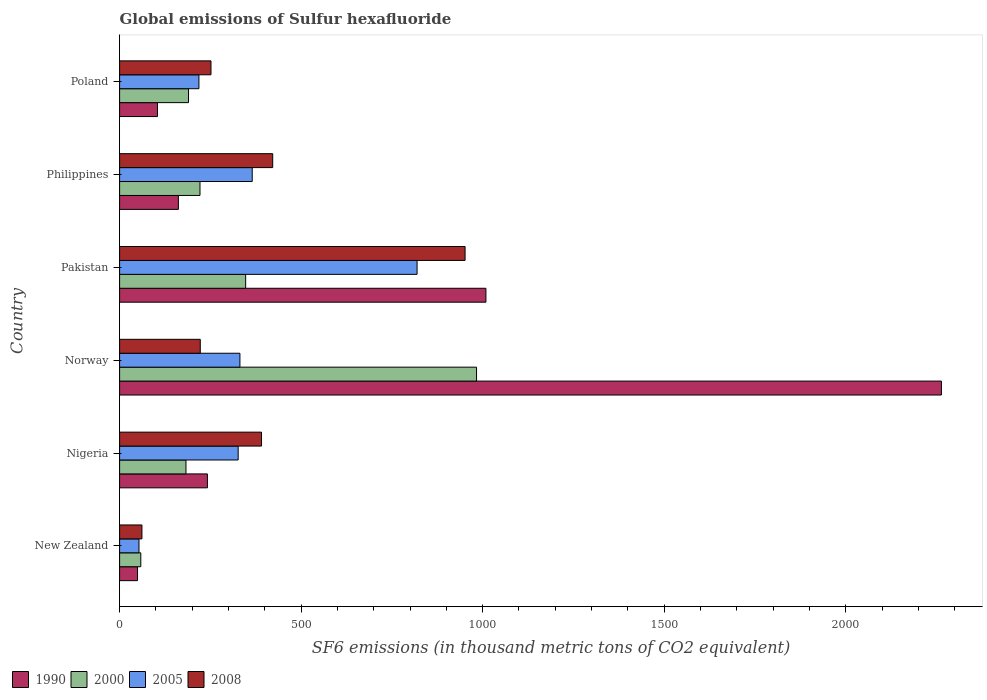Are the number of bars on each tick of the Y-axis equal?
Give a very brief answer. Yes. How many bars are there on the 6th tick from the bottom?
Your answer should be very brief. 4. What is the label of the 6th group of bars from the top?
Ensure brevity in your answer.  New Zealand. In how many cases, is the number of bars for a given country not equal to the number of legend labels?
Keep it short and to the point. 0. What is the global emissions of Sulfur hexafluoride in 1990 in Norway?
Make the answer very short. 2263.6. Across all countries, what is the maximum global emissions of Sulfur hexafluoride in 2000?
Offer a terse response. 983.2. Across all countries, what is the minimum global emissions of Sulfur hexafluoride in 2008?
Offer a very short reply. 61.5. In which country was the global emissions of Sulfur hexafluoride in 2008 minimum?
Keep it short and to the point. New Zealand. What is the total global emissions of Sulfur hexafluoride in 2000 in the graph?
Give a very brief answer. 1982.8. What is the difference between the global emissions of Sulfur hexafluoride in 1990 in New Zealand and that in Nigeria?
Your response must be concise. -192.5. What is the difference between the global emissions of Sulfur hexafluoride in 2000 in Nigeria and the global emissions of Sulfur hexafluoride in 2005 in Norway?
Keep it short and to the point. -148.6. What is the average global emissions of Sulfur hexafluoride in 2005 per country?
Make the answer very short. 352.43. What is the difference between the global emissions of Sulfur hexafluoride in 2005 and global emissions of Sulfur hexafluoride in 2008 in Nigeria?
Give a very brief answer. -64.3. What is the ratio of the global emissions of Sulfur hexafluoride in 2008 in Pakistan to that in Philippines?
Provide a short and direct response. 2.26. Is the global emissions of Sulfur hexafluoride in 1990 in Nigeria less than that in Philippines?
Your response must be concise. No. Is the difference between the global emissions of Sulfur hexafluoride in 2005 in Pakistan and Poland greater than the difference between the global emissions of Sulfur hexafluoride in 2008 in Pakistan and Poland?
Your answer should be very brief. No. What is the difference between the highest and the second highest global emissions of Sulfur hexafluoride in 2008?
Offer a very short reply. 529.9. What is the difference between the highest and the lowest global emissions of Sulfur hexafluoride in 1990?
Give a very brief answer. 2214.2. In how many countries, is the global emissions of Sulfur hexafluoride in 2000 greater than the average global emissions of Sulfur hexafluoride in 2000 taken over all countries?
Your response must be concise. 2. Is the sum of the global emissions of Sulfur hexafluoride in 1990 in Nigeria and Pakistan greater than the maximum global emissions of Sulfur hexafluoride in 2005 across all countries?
Provide a succinct answer. Yes. Is it the case that in every country, the sum of the global emissions of Sulfur hexafluoride in 2005 and global emissions of Sulfur hexafluoride in 2008 is greater than the sum of global emissions of Sulfur hexafluoride in 2000 and global emissions of Sulfur hexafluoride in 1990?
Make the answer very short. No. What does the 4th bar from the top in Pakistan represents?
Your answer should be compact. 1990. Are all the bars in the graph horizontal?
Your answer should be very brief. Yes. Are the values on the major ticks of X-axis written in scientific E-notation?
Make the answer very short. No. Does the graph contain grids?
Your response must be concise. No. Where does the legend appear in the graph?
Provide a short and direct response. Bottom left. How are the legend labels stacked?
Make the answer very short. Horizontal. What is the title of the graph?
Give a very brief answer. Global emissions of Sulfur hexafluoride. What is the label or title of the X-axis?
Your answer should be very brief. SF6 emissions (in thousand metric tons of CO2 equivalent). What is the SF6 emissions (in thousand metric tons of CO2 equivalent) of 1990 in New Zealand?
Your response must be concise. 49.4. What is the SF6 emissions (in thousand metric tons of CO2 equivalent) in 2000 in New Zealand?
Offer a terse response. 58.4. What is the SF6 emissions (in thousand metric tons of CO2 equivalent) in 2005 in New Zealand?
Offer a terse response. 53.4. What is the SF6 emissions (in thousand metric tons of CO2 equivalent) of 2008 in New Zealand?
Provide a succinct answer. 61.5. What is the SF6 emissions (in thousand metric tons of CO2 equivalent) in 1990 in Nigeria?
Give a very brief answer. 241.9. What is the SF6 emissions (in thousand metric tons of CO2 equivalent) in 2000 in Nigeria?
Offer a terse response. 182.8. What is the SF6 emissions (in thousand metric tons of CO2 equivalent) of 2005 in Nigeria?
Your response must be concise. 326.6. What is the SF6 emissions (in thousand metric tons of CO2 equivalent) of 2008 in Nigeria?
Your response must be concise. 390.9. What is the SF6 emissions (in thousand metric tons of CO2 equivalent) in 1990 in Norway?
Give a very brief answer. 2263.6. What is the SF6 emissions (in thousand metric tons of CO2 equivalent) in 2000 in Norway?
Offer a terse response. 983.2. What is the SF6 emissions (in thousand metric tons of CO2 equivalent) in 2005 in Norway?
Your answer should be compact. 331.4. What is the SF6 emissions (in thousand metric tons of CO2 equivalent) of 2008 in Norway?
Offer a very short reply. 222.2. What is the SF6 emissions (in thousand metric tons of CO2 equivalent) in 1990 in Pakistan?
Your answer should be compact. 1009. What is the SF6 emissions (in thousand metric tons of CO2 equivalent) of 2000 in Pakistan?
Make the answer very short. 347.2. What is the SF6 emissions (in thousand metric tons of CO2 equivalent) of 2005 in Pakistan?
Offer a very short reply. 819.4. What is the SF6 emissions (in thousand metric tons of CO2 equivalent) of 2008 in Pakistan?
Keep it short and to the point. 951.6. What is the SF6 emissions (in thousand metric tons of CO2 equivalent) of 1990 in Philippines?
Make the answer very short. 161.9. What is the SF6 emissions (in thousand metric tons of CO2 equivalent) in 2000 in Philippines?
Provide a short and direct response. 221.4. What is the SF6 emissions (in thousand metric tons of CO2 equivalent) in 2005 in Philippines?
Ensure brevity in your answer.  365.3. What is the SF6 emissions (in thousand metric tons of CO2 equivalent) of 2008 in Philippines?
Offer a terse response. 421.7. What is the SF6 emissions (in thousand metric tons of CO2 equivalent) in 1990 in Poland?
Your response must be concise. 104.3. What is the SF6 emissions (in thousand metric tons of CO2 equivalent) of 2000 in Poland?
Ensure brevity in your answer.  189.8. What is the SF6 emissions (in thousand metric tons of CO2 equivalent) in 2005 in Poland?
Your answer should be very brief. 218.5. What is the SF6 emissions (in thousand metric tons of CO2 equivalent) in 2008 in Poland?
Your response must be concise. 251.7. Across all countries, what is the maximum SF6 emissions (in thousand metric tons of CO2 equivalent) of 1990?
Provide a short and direct response. 2263.6. Across all countries, what is the maximum SF6 emissions (in thousand metric tons of CO2 equivalent) in 2000?
Your answer should be very brief. 983.2. Across all countries, what is the maximum SF6 emissions (in thousand metric tons of CO2 equivalent) in 2005?
Offer a terse response. 819.4. Across all countries, what is the maximum SF6 emissions (in thousand metric tons of CO2 equivalent) of 2008?
Give a very brief answer. 951.6. Across all countries, what is the minimum SF6 emissions (in thousand metric tons of CO2 equivalent) in 1990?
Your response must be concise. 49.4. Across all countries, what is the minimum SF6 emissions (in thousand metric tons of CO2 equivalent) of 2000?
Keep it short and to the point. 58.4. Across all countries, what is the minimum SF6 emissions (in thousand metric tons of CO2 equivalent) of 2005?
Make the answer very short. 53.4. Across all countries, what is the minimum SF6 emissions (in thousand metric tons of CO2 equivalent) in 2008?
Your answer should be very brief. 61.5. What is the total SF6 emissions (in thousand metric tons of CO2 equivalent) in 1990 in the graph?
Your response must be concise. 3830.1. What is the total SF6 emissions (in thousand metric tons of CO2 equivalent) in 2000 in the graph?
Your answer should be compact. 1982.8. What is the total SF6 emissions (in thousand metric tons of CO2 equivalent) of 2005 in the graph?
Your answer should be compact. 2114.6. What is the total SF6 emissions (in thousand metric tons of CO2 equivalent) of 2008 in the graph?
Offer a very short reply. 2299.6. What is the difference between the SF6 emissions (in thousand metric tons of CO2 equivalent) of 1990 in New Zealand and that in Nigeria?
Your answer should be very brief. -192.5. What is the difference between the SF6 emissions (in thousand metric tons of CO2 equivalent) of 2000 in New Zealand and that in Nigeria?
Your answer should be very brief. -124.4. What is the difference between the SF6 emissions (in thousand metric tons of CO2 equivalent) in 2005 in New Zealand and that in Nigeria?
Your answer should be compact. -273.2. What is the difference between the SF6 emissions (in thousand metric tons of CO2 equivalent) in 2008 in New Zealand and that in Nigeria?
Your answer should be very brief. -329.4. What is the difference between the SF6 emissions (in thousand metric tons of CO2 equivalent) of 1990 in New Zealand and that in Norway?
Offer a very short reply. -2214.2. What is the difference between the SF6 emissions (in thousand metric tons of CO2 equivalent) of 2000 in New Zealand and that in Norway?
Your answer should be compact. -924.8. What is the difference between the SF6 emissions (in thousand metric tons of CO2 equivalent) of 2005 in New Zealand and that in Norway?
Your response must be concise. -278. What is the difference between the SF6 emissions (in thousand metric tons of CO2 equivalent) of 2008 in New Zealand and that in Norway?
Your answer should be very brief. -160.7. What is the difference between the SF6 emissions (in thousand metric tons of CO2 equivalent) of 1990 in New Zealand and that in Pakistan?
Offer a terse response. -959.6. What is the difference between the SF6 emissions (in thousand metric tons of CO2 equivalent) in 2000 in New Zealand and that in Pakistan?
Provide a succinct answer. -288.8. What is the difference between the SF6 emissions (in thousand metric tons of CO2 equivalent) in 2005 in New Zealand and that in Pakistan?
Provide a succinct answer. -766. What is the difference between the SF6 emissions (in thousand metric tons of CO2 equivalent) in 2008 in New Zealand and that in Pakistan?
Offer a terse response. -890.1. What is the difference between the SF6 emissions (in thousand metric tons of CO2 equivalent) of 1990 in New Zealand and that in Philippines?
Provide a short and direct response. -112.5. What is the difference between the SF6 emissions (in thousand metric tons of CO2 equivalent) in 2000 in New Zealand and that in Philippines?
Your answer should be very brief. -163. What is the difference between the SF6 emissions (in thousand metric tons of CO2 equivalent) in 2005 in New Zealand and that in Philippines?
Your answer should be very brief. -311.9. What is the difference between the SF6 emissions (in thousand metric tons of CO2 equivalent) of 2008 in New Zealand and that in Philippines?
Provide a succinct answer. -360.2. What is the difference between the SF6 emissions (in thousand metric tons of CO2 equivalent) in 1990 in New Zealand and that in Poland?
Provide a succinct answer. -54.9. What is the difference between the SF6 emissions (in thousand metric tons of CO2 equivalent) of 2000 in New Zealand and that in Poland?
Offer a terse response. -131.4. What is the difference between the SF6 emissions (in thousand metric tons of CO2 equivalent) of 2005 in New Zealand and that in Poland?
Offer a very short reply. -165.1. What is the difference between the SF6 emissions (in thousand metric tons of CO2 equivalent) of 2008 in New Zealand and that in Poland?
Provide a short and direct response. -190.2. What is the difference between the SF6 emissions (in thousand metric tons of CO2 equivalent) of 1990 in Nigeria and that in Norway?
Make the answer very short. -2021.7. What is the difference between the SF6 emissions (in thousand metric tons of CO2 equivalent) of 2000 in Nigeria and that in Norway?
Provide a short and direct response. -800.4. What is the difference between the SF6 emissions (in thousand metric tons of CO2 equivalent) of 2008 in Nigeria and that in Norway?
Your response must be concise. 168.7. What is the difference between the SF6 emissions (in thousand metric tons of CO2 equivalent) in 1990 in Nigeria and that in Pakistan?
Provide a short and direct response. -767.1. What is the difference between the SF6 emissions (in thousand metric tons of CO2 equivalent) of 2000 in Nigeria and that in Pakistan?
Provide a short and direct response. -164.4. What is the difference between the SF6 emissions (in thousand metric tons of CO2 equivalent) of 2005 in Nigeria and that in Pakistan?
Offer a terse response. -492.8. What is the difference between the SF6 emissions (in thousand metric tons of CO2 equivalent) in 2008 in Nigeria and that in Pakistan?
Offer a terse response. -560.7. What is the difference between the SF6 emissions (in thousand metric tons of CO2 equivalent) of 2000 in Nigeria and that in Philippines?
Provide a succinct answer. -38.6. What is the difference between the SF6 emissions (in thousand metric tons of CO2 equivalent) of 2005 in Nigeria and that in Philippines?
Provide a short and direct response. -38.7. What is the difference between the SF6 emissions (in thousand metric tons of CO2 equivalent) of 2008 in Nigeria and that in Philippines?
Offer a terse response. -30.8. What is the difference between the SF6 emissions (in thousand metric tons of CO2 equivalent) in 1990 in Nigeria and that in Poland?
Provide a short and direct response. 137.6. What is the difference between the SF6 emissions (in thousand metric tons of CO2 equivalent) in 2005 in Nigeria and that in Poland?
Provide a succinct answer. 108.1. What is the difference between the SF6 emissions (in thousand metric tons of CO2 equivalent) in 2008 in Nigeria and that in Poland?
Your answer should be very brief. 139.2. What is the difference between the SF6 emissions (in thousand metric tons of CO2 equivalent) in 1990 in Norway and that in Pakistan?
Make the answer very short. 1254.6. What is the difference between the SF6 emissions (in thousand metric tons of CO2 equivalent) of 2000 in Norway and that in Pakistan?
Provide a succinct answer. 636. What is the difference between the SF6 emissions (in thousand metric tons of CO2 equivalent) of 2005 in Norway and that in Pakistan?
Give a very brief answer. -488. What is the difference between the SF6 emissions (in thousand metric tons of CO2 equivalent) in 2008 in Norway and that in Pakistan?
Keep it short and to the point. -729.4. What is the difference between the SF6 emissions (in thousand metric tons of CO2 equivalent) in 1990 in Norway and that in Philippines?
Offer a terse response. 2101.7. What is the difference between the SF6 emissions (in thousand metric tons of CO2 equivalent) of 2000 in Norway and that in Philippines?
Give a very brief answer. 761.8. What is the difference between the SF6 emissions (in thousand metric tons of CO2 equivalent) in 2005 in Norway and that in Philippines?
Provide a short and direct response. -33.9. What is the difference between the SF6 emissions (in thousand metric tons of CO2 equivalent) of 2008 in Norway and that in Philippines?
Offer a very short reply. -199.5. What is the difference between the SF6 emissions (in thousand metric tons of CO2 equivalent) in 1990 in Norway and that in Poland?
Offer a terse response. 2159.3. What is the difference between the SF6 emissions (in thousand metric tons of CO2 equivalent) in 2000 in Norway and that in Poland?
Make the answer very short. 793.4. What is the difference between the SF6 emissions (in thousand metric tons of CO2 equivalent) of 2005 in Norway and that in Poland?
Your response must be concise. 112.9. What is the difference between the SF6 emissions (in thousand metric tons of CO2 equivalent) of 2008 in Norway and that in Poland?
Offer a terse response. -29.5. What is the difference between the SF6 emissions (in thousand metric tons of CO2 equivalent) in 1990 in Pakistan and that in Philippines?
Provide a succinct answer. 847.1. What is the difference between the SF6 emissions (in thousand metric tons of CO2 equivalent) of 2000 in Pakistan and that in Philippines?
Give a very brief answer. 125.8. What is the difference between the SF6 emissions (in thousand metric tons of CO2 equivalent) in 2005 in Pakistan and that in Philippines?
Offer a terse response. 454.1. What is the difference between the SF6 emissions (in thousand metric tons of CO2 equivalent) in 2008 in Pakistan and that in Philippines?
Offer a very short reply. 529.9. What is the difference between the SF6 emissions (in thousand metric tons of CO2 equivalent) of 1990 in Pakistan and that in Poland?
Your answer should be compact. 904.7. What is the difference between the SF6 emissions (in thousand metric tons of CO2 equivalent) in 2000 in Pakistan and that in Poland?
Ensure brevity in your answer.  157.4. What is the difference between the SF6 emissions (in thousand metric tons of CO2 equivalent) in 2005 in Pakistan and that in Poland?
Your answer should be very brief. 600.9. What is the difference between the SF6 emissions (in thousand metric tons of CO2 equivalent) of 2008 in Pakistan and that in Poland?
Provide a short and direct response. 699.9. What is the difference between the SF6 emissions (in thousand metric tons of CO2 equivalent) in 1990 in Philippines and that in Poland?
Keep it short and to the point. 57.6. What is the difference between the SF6 emissions (in thousand metric tons of CO2 equivalent) of 2000 in Philippines and that in Poland?
Give a very brief answer. 31.6. What is the difference between the SF6 emissions (in thousand metric tons of CO2 equivalent) of 2005 in Philippines and that in Poland?
Ensure brevity in your answer.  146.8. What is the difference between the SF6 emissions (in thousand metric tons of CO2 equivalent) in 2008 in Philippines and that in Poland?
Offer a terse response. 170. What is the difference between the SF6 emissions (in thousand metric tons of CO2 equivalent) in 1990 in New Zealand and the SF6 emissions (in thousand metric tons of CO2 equivalent) in 2000 in Nigeria?
Give a very brief answer. -133.4. What is the difference between the SF6 emissions (in thousand metric tons of CO2 equivalent) of 1990 in New Zealand and the SF6 emissions (in thousand metric tons of CO2 equivalent) of 2005 in Nigeria?
Provide a succinct answer. -277.2. What is the difference between the SF6 emissions (in thousand metric tons of CO2 equivalent) in 1990 in New Zealand and the SF6 emissions (in thousand metric tons of CO2 equivalent) in 2008 in Nigeria?
Keep it short and to the point. -341.5. What is the difference between the SF6 emissions (in thousand metric tons of CO2 equivalent) of 2000 in New Zealand and the SF6 emissions (in thousand metric tons of CO2 equivalent) of 2005 in Nigeria?
Your response must be concise. -268.2. What is the difference between the SF6 emissions (in thousand metric tons of CO2 equivalent) of 2000 in New Zealand and the SF6 emissions (in thousand metric tons of CO2 equivalent) of 2008 in Nigeria?
Make the answer very short. -332.5. What is the difference between the SF6 emissions (in thousand metric tons of CO2 equivalent) in 2005 in New Zealand and the SF6 emissions (in thousand metric tons of CO2 equivalent) in 2008 in Nigeria?
Ensure brevity in your answer.  -337.5. What is the difference between the SF6 emissions (in thousand metric tons of CO2 equivalent) in 1990 in New Zealand and the SF6 emissions (in thousand metric tons of CO2 equivalent) in 2000 in Norway?
Keep it short and to the point. -933.8. What is the difference between the SF6 emissions (in thousand metric tons of CO2 equivalent) in 1990 in New Zealand and the SF6 emissions (in thousand metric tons of CO2 equivalent) in 2005 in Norway?
Provide a succinct answer. -282. What is the difference between the SF6 emissions (in thousand metric tons of CO2 equivalent) in 1990 in New Zealand and the SF6 emissions (in thousand metric tons of CO2 equivalent) in 2008 in Norway?
Your response must be concise. -172.8. What is the difference between the SF6 emissions (in thousand metric tons of CO2 equivalent) of 2000 in New Zealand and the SF6 emissions (in thousand metric tons of CO2 equivalent) of 2005 in Norway?
Ensure brevity in your answer.  -273. What is the difference between the SF6 emissions (in thousand metric tons of CO2 equivalent) of 2000 in New Zealand and the SF6 emissions (in thousand metric tons of CO2 equivalent) of 2008 in Norway?
Offer a terse response. -163.8. What is the difference between the SF6 emissions (in thousand metric tons of CO2 equivalent) in 2005 in New Zealand and the SF6 emissions (in thousand metric tons of CO2 equivalent) in 2008 in Norway?
Offer a very short reply. -168.8. What is the difference between the SF6 emissions (in thousand metric tons of CO2 equivalent) in 1990 in New Zealand and the SF6 emissions (in thousand metric tons of CO2 equivalent) in 2000 in Pakistan?
Your answer should be compact. -297.8. What is the difference between the SF6 emissions (in thousand metric tons of CO2 equivalent) of 1990 in New Zealand and the SF6 emissions (in thousand metric tons of CO2 equivalent) of 2005 in Pakistan?
Offer a very short reply. -770. What is the difference between the SF6 emissions (in thousand metric tons of CO2 equivalent) in 1990 in New Zealand and the SF6 emissions (in thousand metric tons of CO2 equivalent) in 2008 in Pakistan?
Your response must be concise. -902.2. What is the difference between the SF6 emissions (in thousand metric tons of CO2 equivalent) in 2000 in New Zealand and the SF6 emissions (in thousand metric tons of CO2 equivalent) in 2005 in Pakistan?
Offer a very short reply. -761. What is the difference between the SF6 emissions (in thousand metric tons of CO2 equivalent) of 2000 in New Zealand and the SF6 emissions (in thousand metric tons of CO2 equivalent) of 2008 in Pakistan?
Your response must be concise. -893.2. What is the difference between the SF6 emissions (in thousand metric tons of CO2 equivalent) of 2005 in New Zealand and the SF6 emissions (in thousand metric tons of CO2 equivalent) of 2008 in Pakistan?
Keep it short and to the point. -898.2. What is the difference between the SF6 emissions (in thousand metric tons of CO2 equivalent) in 1990 in New Zealand and the SF6 emissions (in thousand metric tons of CO2 equivalent) in 2000 in Philippines?
Make the answer very short. -172. What is the difference between the SF6 emissions (in thousand metric tons of CO2 equivalent) in 1990 in New Zealand and the SF6 emissions (in thousand metric tons of CO2 equivalent) in 2005 in Philippines?
Offer a terse response. -315.9. What is the difference between the SF6 emissions (in thousand metric tons of CO2 equivalent) in 1990 in New Zealand and the SF6 emissions (in thousand metric tons of CO2 equivalent) in 2008 in Philippines?
Ensure brevity in your answer.  -372.3. What is the difference between the SF6 emissions (in thousand metric tons of CO2 equivalent) of 2000 in New Zealand and the SF6 emissions (in thousand metric tons of CO2 equivalent) of 2005 in Philippines?
Your response must be concise. -306.9. What is the difference between the SF6 emissions (in thousand metric tons of CO2 equivalent) of 2000 in New Zealand and the SF6 emissions (in thousand metric tons of CO2 equivalent) of 2008 in Philippines?
Provide a succinct answer. -363.3. What is the difference between the SF6 emissions (in thousand metric tons of CO2 equivalent) of 2005 in New Zealand and the SF6 emissions (in thousand metric tons of CO2 equivalent) of 2008 in Philippines?
Offer a terse response. -368.3. What is the difference between the SF6 emissions (in thousand metric tons of CO2 equivalent) of 1990 in New Zealand and the SF6 emissions (in thousand metric tons of CO2 equivalent) of 2000 in Poland?
Offer a very short reply. -140.4. What is the difference between the SF6 emissions (in thousand metric tons of CO2 equivalent) in 1990 in New Zealand and the SF6 emissions (in thousand metric tons of CO2 equivalent) in 2005 in Poland?
Keep it short and to the point. -169.1. What is the difference between the SF6 emissions (in thousand metric tons of CO2 equivalent) of 1990 in New Zealand and the SF6 emissions (in thousand metric tons of CO2 equivalent) of 2008 in Poland?
Your response must be concise. -202.3. What is the difference between the SF6 emissions (in thousand metric tons of CO2 equivalent) in 2000 in New Zealand and the SF6 emissions (in thousand metric tons of CO2 equivalent) in 2005 in Poland?
Keep it short and to the point. -160.1. What is the difference between the SF6 emissions (in thousand metric tons of CO2 equivalent) in 2000 in New Zealand and the SF6 emissions (in thousand metric tons of CO2 equivalent) in 2008 in Poland?
Provide a succinct answer. -193.3. What is the difference between the SF6 emissions (in thousand metric tons of CO2 equivalent) in 2005 in New Zealand and the SF6 emissions (in thousand metric tons of CO2 equivalent) in 2008 in Poland?
Provide a short and direct response. -198.3. What is the difference between the SF6 emissions (in thousand metric tons of CO2 equivalent) of 1990 in Nigeria and the SF6 emissions (in thousand metric tons of CO2 equivalent) of 2000 in Norway?
Offer a terse response. -741.3. What is the difference between the SF6 emissions (in thousand metric tons of CO2 equivalent) in 1990 in Nigeria and the SF6 emissions (in thousand metric tons of CO2 equivalent) in 2005 in Norway?
Offer a terse response. -89.5. What is the difference between the SF6 emissions (in thousand metric tons of CO2 equivalent) of 1990 in Nigeria and the SF6 emissions (in thousand metric tons of CO2 equivalent) of 2008 in Norway?
Your response must be concise. 19.7. What is the difference between the SF6 emissions (in thousand metric tons of CO2 equivalent) of 2000 in Nigeria and the SF6 emissions (in thousand metric tons of CO2 equivalent) of 2005 in Norway?
Keep it short and to the point. -148.6. What is the difference between the SF6 emissions (in thousand metric tons of CO2 equivalent) in 2000 in Nigeria and the SF6 emissions (in thousand metric tons of CO2 equivalent) in 2008 in Norway?
Your answer should be compact. -39.4. What is the difference between the SF6 emissions (in thousand metric tons of CO2 equivalent) in 2005 in Nigeria and the SF6 emissions (in thousand metric tons of CO2 equivalent) in 2008 in Norway?
Provide a succinct answer. 104.4. What is the difference between the SF6 emissions (in thousand metric tons of CO2 equivalent) of 1990 in Nigeria and the SF6 emissions (in thousand metric tons of CO2 equivalent) of 2000 in Pakistan?
Offer a very short reply. -105.3. What is the difference between the SF6 emissions (in thousand metric tons of CO2 equivalent) in 1990 in Nigeria and the SF6 emissions (in thousand metric tons of CO2 equivalent) in 2005 in Pakistan?
Ensure brevity in your answer.  -577.5. What is the difference between the SF6 emissions (in thousand metric tons of CO2 equivalent) in 1990 in Nigeria and the SF6 emissions (in thousand metric tons of CO2 equivalent) in 2008 in Pakistan?
Your response must be concise. -709.7. What is the difference between the SF6 emissions (in thousand metric tons of CO2 equivalent) of 2000 in Nigeria and the SF6 emissions (in thousand metric tons of CO2 equivalent) of 2005 in Pakistan?
Offer a terse response. -636.6. What is the difference between the SF6 emissions (in thousand metric tons of CO2 equivalent) of 2000 in Nigeria and the SF6 emissions (in thousand metric tons of CO2 equivalent) of 2008 in Pakistan?
Make the answer very short. -768.8. What is the difference between the SF6 emissions (in thousand metric tons of CO2 equivalent) of 2005 in Nigeria and the SF6 emissions (in thousand metric tons of CO2 equivalent) of 2008 in Pakistan?
Your response must be concise. -625. What is the difference between the SF6 emissions (in thousand metric tons of CO2 equivalent) in 1990 in Nigeria and the SF6 emissions (in thousand metric tons of CO2 equivalent) in 2000 in Philippines?
Offer a very short reply. 20.5. What is the difference between the SF6 emissions (in thousand metric tons of CO2 equivalent) in 1990 in Nigeria and the SF6 emissions (in thousand metric tons of CO2 equivalent) in 2005 in Philippines?
Ensure brevity in your answer.  -123.4. What is the difference between the SF6 emissions (in thousand metric tons of CO2 equivalent) of 1990 in Nigeria and the SF6 emissions (in thousand metric tons of CO2 equivalent) of 2008 in Philippines?
Give a very brief answer. -179.8. What is the difference between the SF6 emissions (in thousand metric tons of CO2 equivalent) of 2000 in Nigeria and the SF6 emissions (in thousand metric tons of CO2 equivalent) of 2005 in Philippines?
Give a very brief answer. -182.5. What is the difference between the SF6 emissions (in thousand metric tons of CO2 equivalent) in 2000 in Nigeria and the SF6 emissions (in thousand metric tons of CO2 equivalent) in 2008 in Philippines?
Provide a succinct answer. -238.9. What is the difference between the SF6 emissions (in thousand metric tons of CO2 equivalent) in 2005 in Nigeria and the SF6 emissions (in thousand metric tons of CO2 equivalent) in 2008 in Philippines?
Keep it short and to the point. -95.1. What is the difference between the SF6 emissions (in thousand metric tons of CO2 equivalent) in 1990 in Nigeria and the SF6 emissions (in thousand metric tons of CO2 equivalent) in 2000 in Poland?
Your response must be concise. 52.1. What is the difference between the SF6 emissions (in thousand metric tons of CO2 equivalent) of 1990 in Nigeria and the SF6 emissions (in thousand metric tons of CO2 equivalent) of 2005 in Poland?
Your response must be concise. 23.4. What is the difference between the SF6 emissions (in thousand metric tons of CO2 equivalent) of 1990 in Nigeria and the SF6 emissions (in thousand metric tons of CO2 equivalent) of 2008 in Poland?
Provide a short and direct response. -9.8. What is the difference between the SF6 emissions (in thousand metric tons of CO2 equivalent) in 2000 in Nigeria and the SF6 emissions (in thousand metric tons of CO2 equivalent) in 2005 in Poland?
Make the answer very short. -35.7. What is the difference between the SF6 emissions (in thousand metric tons of CO2 equivalent) of 2000 in Nigeria and the SF6 emissions (in thousand metric tons of CO2 equivalent) of 2008 in Poland?
Offer a terse response. -68.9. What is the difference between the SF6 emissions (in thousand metric tons of CO2 equivalent) of 2005 in Nigeria and the SF6 emissions (in thousand metric tons of CO2 equivalent) of 2008 in Poland?
Provide a short and direct response. 74.9. What is the difference between the SF6 emissions (in thousand metric tons of CO2 equivalent) of 1990 in Norway and the SF6 emissions (in thousand metric tons of CO2 equivalent) of 2000 in Pakistan?
Offer a very short reply. 1916.4. What is the difference between the SF6 emissions (in thousand metric tons of CO2 equivalent) in 1990 in Norway and the SF6 emissions (in thousand metric tons of CO2 equivalent) in 2005 in Pakistan?
Provide a succinct answer. 1444.2. What is the difference between the SF6 emissions (in thousand metric tons of CO2 equivalent) in 1990 in Norway and the SF6 emissions (in thousand metric tons of CO2 equivalent) in 2008 in Pakistan?
Your answer should be compact. 1312. What is the difference between the SF6 emissions (in thousand metric tons of CO2 equivalent) of 2000 in Norway and the SF6 emissions (in thousand metric tons of CO2 equivalent) of 2005 in Pakistan?
Ensure brevity in your answer.  163.8. What is the difference between the SF6 emissions (in thousand metric tons of CO2 equivalent) in 2000 in Norway and the SF6 emissions (in thousand metric tons of CO2 equivalent) in 2008 in Pakistan?
Keep it short and to the point. 31.6. What is the difference between the SF6 emissions (in thousand metric tons of CO2 equivalent) in 2005 in Norway and the SF6 emissions (in thousand metric tons of CO2 equivalent) in 2008 in Pakistan?
Provide a succinct answer. -620.2. What is the difference between the SF6 emissions (in thousand metric tons of CO2 equivalent) of 1990 in Norway and the SF6 emissions (in thousand metric tons of CO2 equivalent) of 2000 in Philippines?
Provide a short and direct response. 2042.2. What is the difference between the SF6 emissions (in thousand metric tons of CO2 equivalent) of 1990 in Norway and the SF6 emissions (in thousand metric tons of CO2 equivalent) of 2005 in Philippines?
Offer a very short reply. 1898.3. What is the difference between the SF6 emissions (in thousand metric tons of CO2 equivalent) in 1990 in Norway and the SF6 emissions (in thousand metric tons of CO2 equivalent) in 2008 in Philippines?
Provide a succinct answer. 1841.9. What is the difference between the SF6 emissions (in thousand metric tons of CO2 equivalent) of 2000 in Norway and the SF6 emissions (in thousand metric tons of CO2 equivalent) of 2005 in Philippines?
Provide a short and direct response. 617.9. What is the difference between the SF6 emissions (in thousand metric tons of CO2 equivalent) in 2000 in Norway and the SF6 emissions (in thousand metric tons of CO2 equivalent) in 2008 in Philippines?
Ensure brevity in your answer.  561.5. What is the difference between the SF6 emissions (in thousand metric tons of CO2 equivalent) of 2005 in Norway and the SF6 emissions (in thousand metric tons of CO2 equivalent) of 2008 in Philippines?
Offer a very short reply. -90.3. What is the difference between the SF6 emissions (in thousand metric tons of CO2 equivalent) of 1990 in Norway and the SF6 emissions (in thousand metric tons of CO2 equivalent) of 2000 in Poland?
Give a very brief answer. 2073.8. What is the difference between the SF6 emissions (in thousand metric tons of CO2 equivalent) of 1990 in Norway and the SF6 emissions (in thousand metric tons of CO2 equivalent) of 2005 in Poland?
Keep it short and to the point. 2045.1. What is the difference between the SF6 emissions (in thousand metric tons of CO2 equivalent) of 1990 in Norway and the SF6 emissions (in thousand metric tons of CO2 equivalent) of 2008 in Poland?
Make the answer very short. 2011.9. What is the difference between the SF6 emissions (in thousand metric tons of CO2 equivalent) in 2000 in Norway and the SF6 emissions (in thousand metric tons of CO2 equivalent) in 2005 in Poland?
Make the answer very short. 764.7. What is the difference between the SF6 emissions (in thousand metric tons of CO2 equivalent) of 2000 in Norway and the SF6 emissions (in thousand metric tons of CO2 equivalent) of 2008 in Poland?
Your answer should be very brief. 731.5. What is the difference between the SF6 emissions (in thousand metric tons of CO2 equivalent) in 2005 in Norway and the SF6 emissions (in thousand metric tons of CO2 equivalent) in 2008 in Poland?
Offer a terse response. 79.7. What is the difference between the SF6 emissions (in thousand metric tons of CO2 equivalent) in 1990 in Pakistan and the SF6 emissions (in thousand metric tons of CO2 equivalent) in 2000 in Philippines?
Your response must be concise. 787.6. What is the difference between the SF6 emissions (in thousand metric tons of CO2 equivalent) of 1990 in Pakistan and the SF6 emissions (in thousand metric tons of CO2 equivalent) of 2005 in Philippines?
Your answer should be compact. 643.7. What is the difference between the SF6 emissions (in thousand metric tons of CO2 equivalent) of 1990 in Pakistan and the SF6 emissions (in thousand metric tons of CO2 equivalent) of 2008 in Philippines?
Your answer should be compact. 587.3. What is the difference between the SF6 emissions (in thousand metric tons of CO2 equivalent) in 2000 in Pakistan and the SF6 emissions (in thousand metric tons of CO2 equivalent) in 2005 in Philippines?
Give a very brief answer. -18.1. What is the difference between the SF6 emissions (in thousand metric tons of CO2 equivalent) in 2000 in Pakistan and the SF6 emissions (in thousand metric tons of CO2 equivalent) in 2008 in Philippines?
Offer a very short reply. -74.5. What is the difference between the SF6 emissions (in thousand metric tons of CO2 equivalent) in 2005 in Pakistan and the SF6 emissions (in thousand metric tons of CO2 equivalent) in 2008 in Philippines?
Offer a very short reply. 397.7. What is the difference between the SF6 emissions (in thousand metric tons of CO2 equivalent) of 1990 in Pakistan and the SF6 emissions (in thousand metric tons of CO2 equivalent) of 2000 in Poland?
Your response must be concise. 819.2. What is the difference between the SF6 emissions (in thousand metric tons of CO2 equivalent) of 1990 in Pakistan and the SF6 emissions (in thousand metric tons of CO2 equivalent) of 2005 in Poland?
Make the answer very short. 790.5. What is the difference between the SF6 emissions (in thousand metric tons of CO2 equivalent) of 1990 in Pakistan and the SF6 emissions (in thousand metric tons of CO2 equivalent) of 2008 in Poland?
Your response must be concise. 757.3. What is the difference between the SF6 emissions (in thousand metric tons of CO2 equivalent) in 2000 in Pakistan and the SF6 emissions (in thousand metric tons of CO2 equivalent) in 2005 in Poland?
Make the answer very short. 128.7. What is the difference between the SF6 emissions (in thousand metric tons of CO2 equivalent) of 2000 in Pakistan and the SF6 emissions (in thousand metric tons of CO2 equivalent) of 2008 in Poland?
Your response must be concise. 95.5. What is the difference between the SF6 emissions (in thousand metric tons of CO2 equivalent) of 2005 in Pakistan and the SF6 emissions (in thousand metric tons of CO2 equivalent) of 2008 in Poland?
Offer a terse response. 567.7. What is the difference between the SF6 emissions (in thousand metric tons of CO2 equivalent) in 1990 in Philippines and the SF6 emissions (in thousand metric tons of CO2 equivalent) in 2000 in Poland?
Give a very brief answer. -27.9. What is the difference between the SF6 emissions (in thousand metric tons of CO2 equivalent) in 1990 in Philippines and the SF6 emissions (in thousand metric tons of CO2 equivalent) in 2005 in Poland?
Give a very brief answer. -56.6. What is the difference between the SF6 emissions (in thousand metric tons of CO2 equivalent) of 1990 in Philippines and the SF6 emissions (in thousand metric tons of CO2 equivalent) of 2008 in Poland?
Provide a succinct answer. -89.8. What is the difference between the SF6 emissions (in thousand metric tons of CO2 equivalent) in 2000 in Philippines and the SF6 emissions (in thousand metric tons of CO2 equivalent) in 2008 in Poland?
Your response must be concise. -30.3. What is the difference between the SF6 emissions (in thousand metric tons of CO2 equivalent) of 2005 in Philippines and the SF6 emissions (in thousand metric tons of CO2 equivalent) of 2008 in Poland?
Your answer should be compact. 113.6. What is the average SF6 emissions (in thousand metric tons of CO2 equivalent) of 1990 per country?
Provide a succinct answer. 638.35. What is the average SF6 emissions (in thousand metric tons of CO2 equivalent) of 2000 per country?
Provide a succinct answer. 330.47. What is the average SF6 emissions (in thousand metric tons of CO2 equivalent) of 2005 per country?
Offer a terse response. 352.43. What is the average SF6 emissions (in thousand metric tons of CO2 equivalent) in 2008 per country?
Give a very brief answer. 383.27. What is the difference between the SF6 emissions (in thousand metric tons of CO2 equivalent) in 1990 and SF6 emissions (in thousand metric tons of CO2 equivalent) in 2000 in New Zealand?
Give a very brief answer. -9. What is the difference between the SF6 emissions (in thousand metric tons of CO2 equivalent) in 2000 and SF6 emissions (in thousand metric tons of CO2 equivalent) in 2005 in New Zealand?
Give a very brief answer. 5. What is the difference between the SF6 emissions (in thousand metric tons of CO2 equivalent) in 1990 and SF6 emissions (in thousand metric tons of CO2 equivalent) in 2000 in Nigeria?
Your response must be concise. 59.1. What is the difference between the SF6 emissions (in thousand metric tons of CO2 equivalent) of 1990 and SF6 emissions (in thousand metric tons of CO2 equivalent) of 2005 in Nigeria?
Ensure brevity in your answer.  -84.7. What is the difference between the SF6 emissions (in thousand metric tons of CO2 equivalent) in 1990 and SF6 emissions (in thousand metric tons of CO2 equivalent) in 2008 in Nigeria?
Offer a very short reply. -149. What is the difference between the SF6 emissions (in thousand metric tons of CO2 equivalent) in 2000 and SF6 emissions (in thousand metric tons of CO2 equivalent) in 2005 in Nigeria?
Your response must be concise. -143.8. What is the difference between the SF6 emissions (in thousand metric tons of CO2 equivalent) in 2000 and SF6 emissions (in thousand metric tons of CO2 equivalent) in 2008 in Nigeria?
Give a very brief answer. -208.1. What is the difference between the SF6 emissions (in thousand metric tons of CO2 equivalent) of 2005 and SF6 emissions (in thousand metric tons of CO2 equivalent) of 2008 in Nigeria?
Keep it short and to the point. -64.3. What is the difference between the SF6 emissions (in thousand metric tons of CO2 equivalent) in 1990 and SF6 emissions (in thousand metric tons of CO2 equivalent) in 2000 in Norway?
Keep it short and to the point. 1280.4. What is the difference between the SF6 emissions (in thousand metric tons of CO2 equivalent) of 1990 and SF6 emissions (in thousand metric tons of CO2 equivalent) of 2005 in Norway?
Give a very brief answer. 1932.2. What is the difference between the SF6 emissions (in thousand metric tons of CO2 equivalent) in 1990 and SF6 emissions (in thousand metric tons of CO2 equivalent) in 2008 in Norway?
Your response must be concise. 2041.4. What is the difference between the SF6 emissions (in thousand metric tons of CO2 equivalent) of 2000 and SF6 emissions (in thousand metric tons of CO2 equivalent) of 2005 in Norway?
Your answer should be very brief. 651.8. What is the difference between the SF6 emissions (in thousand metric tons of CO2 equivalent) of 2000 and SF6 emissions (in thousand metric tons of CO2 equivalent) of 2008 in Norway?
Provide a succinct answer. 761. What is the difference between the SF6 emissions (in thousand metric tons of CO2 equivalent) in 2005 and SF6 emissions (in thousand metric tons of CO2 equivalent) in 2008 in Norway?
Give a very brief answer. 109.2. What is the difference between the SF6 emissions (in thousand metric tons of CO2 equivalent) of 1990 and SF6 emissions (in thousand metric tons of CO2 equivalent) of 2000 in Pakistan?
Offer a terse response. 661.8. What is the difference between the SF6 emissions (in thousand metric tons of CO2 equivalent) in 1990 and SF6 emissions (in thousand metric tons of CO2 equivalent) in 2005 in Pakistan?
Offer a terse response. 189.6. What is the difference between the SF6 emissions (in thousand metric tons of CO2 equivalent) of 1990 and SF6 emissions (in thousand metric tons of CO2 equivalent) of 2008 in Pakistan?
Give a very brief answer. 57.4. What is the difference between the SF6 emissions (in thousand metric tons of CO2 equivalent) in 2000 and SF6 emissions (in thousand metric tons of CO2 equivalent) in 2005 in Pakistan?
Offer a very short reply. -472.2. What is the difference between the SF6 emissions (in thousand metric tons of CO2 equivalent) of 2000 and SF6 emissions (in thousand metric tons of CO2 equivalent) of 2008 in Pakistan?
Ensure brevity in your answer.  -604.4. What is the difference between the SF6 emissions (in thousand metric tons of CO2 equivalent) of 2005 and SF6 emissions (in thousand metric tons of CO2 equivalent) of 2008 in Pakistan?
Your answer should be very brief. -132.2. What is the difference between the SF6 emissions (in thousand metric tons of CO2 equivalent) of 1990 and SF6 emissions (in thousand metric tons of CO2 equivalent) of 2000 in Philippines?
Keep it short and to the point. -59.5. What is the difference between the SF6 emissions (in thousand metric tons of CO2 equivalent) of 1990 and SF6 emissions (in thousand metric tons of CO2 equivalent) of 2005 in Philippines?
Make the answer very short. -203.4. What is the difference between the SF6 emissions (in thousand metric tons of CO2 equivalent) of 1990 and SF6 emissions (in thousand metric tons of CO2 equivalent) of 2008 in Philippines?
Keep it short and to the point. -259.8. What is the difference between the SF6 emissions (in thousand metric tons of CO2 equivalent) of 2000 and SF6 emissions (in thousand metric tons of CO2 equivalent) of 2005 in Philippines?
Ensure brevity in your answer.  -143.9. What is the difference between the SF6 emissions (in thousand metric tons of CO2 equivalent) of 2000 and SF6 emissions (in thousand metric tons of CO2 equivalent) of 2008 in Philippines?
Provide a short and direct response. -200.3. What is the difference between the SF6 emissions (in thousand metric tons of CO2 equivalent) in 2005 and SF6 emissions (in thousand metric tons of CO2 equivalent) in 2008 in Philippines?
Ensure brevity in your answer.  -56.4. What is the difference between the SF6 emissions (in thousand metric tons of CO2 equivalent) of 1990 and SF6 emissions (in thousand metric tons of CO2 equivalent) of 2000 in Poland?
Ensure brevity in your answer.  -85.5. What is the difference between the SF6 emissions (in thousand metric tons of CO2 equivalent) of 1990 and SF6 emissions (in thousand metric tons of CO2 equivalent) of 2005 in Poland?
Your response must be concise. -114.2. What is the difference between the SF6 emissions (in thousand metric tons of CO2 equivalent) in 1990 and SF6 emissions (in thousand metric tons of CO2 equivalent) in 2008 in Poland?
Provide a succinct answer. -147.4. What is the difference between the SF6 emissions (in thousand metric tons of CO2 equivalent) in 2000 and SF6 emissions (in thousand metric tons of CO2 equivalent) in 2005 in Poland?
Give a very brief answer. -28.7. What is the difference between the SF6 emissions (in thousand metric tons of CO2 equivalent) in 2000 and SF6 emissions (in thousand metric tons of CO2 equivalent) in 2008 in Poland?
Your answer should be very brief. -61.9. What is the difference between the SF6 emissions (in thousand metric tons of CO2 equivalent) in 2005 and SF6 emissions (in thousand metric tons of CO2 equivalent) in 2008 in Poland?
Offer a very short reply. -33.2. What is the ratio of the SF6 emissions (in thousand metric tons of CO2 equivalent) in 1990 in New Zealand to that in Nigeria?
Keep it short and to the point. 0.2. What is the ratio of the SF6 emissions (in thousand metric tons of CO2 equivalent) of 2000 in New Zealand to that in Nigeria?
Provide a short and direct response. 0.32. What is the ratio of the SF6 emissions (in thousand metric tons of CO2 equivalent) in 2005 in New Zealand to that in Nigeria?
Your response must be concise. 0.16. What is the ratio of the SF6 emissions (in thousand metric tons of CO2 equivalent) in 2008 in New Zealand to that in Nigeria?
Your answer should be very brief. 0.16. What is the ratio of the SF6 emissions (in thousand metric tons of CO2 equivalent) in 1990 in New Zealand to that in Norway?
Provide a succinct answer. 0.02. What is the ratio of the SF6 emissions (in thousand metric tons of CO2 equivalent) in 2000 in New Zealand to that in Norway?
Offer a very short reply. 0.06. What is the ratio of the SF6 emissions (in thousand metric tons of CO2 equivalent) of 2005 in New Zealand to that in Norway?
Your answer should be compact. 0.16. What is the ratio of the SF6 emissions (in thousand metric tons of CO2 equivalent) of 2008 in New Zealand to that in Norway?
Offer a very short reply. 0.28. What is the ratio of the SF6 emissions (in thousand metric tons of CO2 equivalent) in 1990 in New Zealand to that in Pakistan?
Your answer should be very brief. 0.05. What is the ratio of the SF6 emissions (in thousand metric tons of CO2 equivalent) of 2000 in New Zealand to that in Pakistan?
Your answer should be compact. 0.17. What is the ratio of the SF6 emissions (in thousand metric tons of CO2 equivalent) of 2005 in New Zealand to that in Pakistan?
Your response must be concise. 0.07. What is the ratio of the SF6 emissions (in thousand metric tons of CO2 equivalent) in 2008 in New Zealand to that in Pakistan?
Provide a short and direct response. 0.06. What is the ratio of the SF6 emissions (in thousand metric tons of CO2 equivalent) of 1990 in New Zealand to that in Philippines?
Your answer should be compact. 0.31. What is the ratio of the SF6 emissions (in thousand metric tons of CO2 equivalent) in 2000 in New Zealand to that in Philippines?
Offer a very short reply. 0.26. What is the ratio of the SF6 emissions (in thousand metric tons of CO2 equivalent) of 2005 in New Zealand to that in Philippines?
Your answer should be compact. 0.15. What is the ratio of the SF6 emissions (in thousand metric tons of CO2 equivalent) of 2008 in New Zealand to that in Philippines?
Give a very brief answer. 0.15. What is the ratio of the SF6 emissions (in thousand metric tons of CO2 equivalent) of 1990 in New Zealand to that in Poland?
Your response must be concise. 0.47. What is the ratio of the SF6 emissions (in thousand metric tons of CO2 equivalent) of 2000 in New Zealand to that in Poland?
Offer a terse response. 0.31. What is the ratio of the SF6 emissions (in thousand metric tons of CO2 equivalent) in 2005 in New Zealand to that in Poland?
Ensure brevity in your answer.  0.24. What is the ratio of the SF6 emissions (in thousand metric tons of CO2 equivalent) of 2008 in New Zealand to that in Poland?
Your answer should be very brief. 0.24. What is the ratio of the SF6 emissions (in thousand metric tons of CO2 equivalent) in 1990 in Nigeria to that in Norway?
Provide a succinct answer. 0.11. What is the ratio of the SF6 emissions (in thousand metric tons of CO2 equivalent) of 2000 in Nigeria to that in Norway?
Give a very brief answer. 0.19. What is the ratio of the SF6 emissions (in thousand metric tons of CO2 equivalent) of 2005 in Nigeria to that in Norway?
Your answer should be very brief. 0.99. What is the ratio of the SF6 emissions (in thousand metric tons of CO2 equivalent) of 2008 in Nigeria to that in Norway?
Keep it short and to the point. 1.76. What is the ratio of the SF6 emissions (in thousand metric tons of CO2 equivalent) of 1990 in Nigeria to that in Pakistan?
Ensure brevity in your answer.  0.24. What is the ratio of the SF6 emissions (in thousand metric tons of CO2 equivalent) in 2000 in Nigeria to that in Pakistan?
Your answer should be very brief. 0.53. What is the ratio of the SF6 emissions (in thousand metric tons of CO2 equivalent) of 2005 in Nigeria to that in Pakistan?
Provide a short and direct response. 0.4. What is the ratio of the SF6 emissions (in thousand metric tons of CO2 equivalent) of 2008 in Nigeria to that in Pakistan?
Your response must be concise. 0.41. What is the ratio of the SF6 emissions (in thousand metric tons of CO2 equivalent) in 1990 in Nigeria to that in Philippines?
Ensure brevity in your answer.  1.49. What is the ratio of the SF6 emissions (in thousand metric tons of CO2 equivalent) in 2000 in Nigeria to that in Philippines?
Give a very brief answer. 0.83. What is the ratio of the SF6 emissions (in thousand metric tons of CO2 equivalent) in 2005 in Nigeria to that in Philippines?
Your response must be concise. 0.89. What is the ratio of the SF6 emissions (in thousand metric tons of CO2 equivalent) of 2008 in Nigeria to that in Philippines?
Make the answer very short. 0.93. What is the ratio of the SF6 emissions (in thousand metric tons of CO2 equivalent) of 1990 in Nigeria to that in Poland?
Make the answer very short. 2.32. What is the ratio of the SF6 emissions (in thousand metric tons of CO2 equivalent) of 2000 in Nigeria to that in Poland?
Give a very brief answer. 0.96. What is the ratio of the SF6 emissions (in thousand metric tons of CO2 equivalent) in 2005 in Nigeria to that in Poland?
Offer a terse response. 1.49. What is the ratio of the SF6 emissions (in thousand metric tons of CO2 equivalent) of 2008 in Nigeria to that in Poland?
Your response must be concise. 1.55. What is the ratio of the SF6 emissions (in thousand metric tons of CO2 equivalent) in 1990 in Norway to that in Pakistan?
Ensure brevity in your answer.  2.24. What is the ratio of the SF6 emissions (in thousand metric tons of CO2 equivalent) in 2000 in Norway to that in Pakistan?
Your answer should be compact. 2.83. What is the ratio of the SF6 emissions (in thousand metric tons of CO2 equivalent) of 2005 in Norway to that in Pakistan?
Keep it short and to the point. 0.4. What is the ratio of the SF6 emissions (in thousand metric tons of CO2 equivalent) of 2008 in Norway to that in Pakistan?
Offer a terse response. 0.23. What is the ratio of the SF6 emissions (in thousand metric tons of CO2 equivalent) of 1990 in Norway to that in Philippines?
Provide a short and direct response. 13.98. What is the ratio of the SF6 emissions (in thousand metric tons of CO2 equivalent) in 2000 in Norway to that in Philippines?
Provide a succinct answer. 4.44. What is the ratio of the SF6 emissions (in thousand metric tons of CO2 equivalent) in 2005 in Norway to that in Philippines?
Offer a very short reply. 0.91. What is the ratio of the SF6 emissions (in thousand metric tons of CO2 equivalent) of 2008 in Norway to that in Philippines?
Provide a succinct answer. 0.53. What is the ratio of the SF6 emissions (in thousand metric tons of CO2 equivalent) in 1990 in Norway to that in Poland?
Offer a terse response. 21.7. What is the ratio of the SF6 emissions (in thousand metric tons of CO2 equivalent) in 2000 in Norway to that in Poland?
Your answer should be very brief. 5.18. What is the ratio of the SF6 emissions (in thousand metric tons of CO2 equivalent) in 2005 in Norway to that in Poland?
Provide a short and direct response. 1.52. What is the ratio of the SF6 emissions (in thousand metric tons of CO2 equivalent) of 2008 in Norway to that in Poland?
Offer a very short reply. 0.88. What is the ratio of the SF6 emissions (in thousand metric tons of CO2 equivalent) in 1990 in Pakistan to that in Philippines?
Provide a short and direct response. 6.23. What is the ratio of the SF6 emissions (in thousand metric tons of CO2 equivalent) of 2000 in Pakistan to that in Philippines?
Offer a terse response. 1.57. What is the ratio of the SF6 emissions (in thousand metric tons of CO2 equivalent) of 2005 in Pakistan to that in Philippines?
Your answer should be compact. 2.24. What is the ratio of the SF6 emissions (in thousand metric tons of CO2 equivalent) of 2008 in Pakistan to that in Philippines?
Provide a succinct answer. 2.26. What is the ratio of the SF6 emissions (in thousand metric tons of CO2 equivalent) in 1990 in Pakistan to that in Poland?
Offer a terse response. 9.67. What is the ratio of the SF6 emissions (in thousand metric tons of CO2 equivalent) of 2000 in Pakistan to that in Poland?
Give a very brief answer. 1.83. What is the ratio of the SF6 emissions (in thousand metric tons of CO2 equivalent) in 2005 in Pakistan to that in Poland?
Keep it short and to the point. 3.75. What is the ratio of the SF6 emissions (in thousand metric tons of CO2 equivalent) in 2008 in Pakistan to that in Poland?
Your response must be concise. 3.78. What is the ratio of the SF6 emissions (in thousand metric tons of CO2 equivalent) in 1990 in Philippines to that in Poland?
Ensure brevity in your answer.  1.55. What is the ratio of the SF6 emissions (in thousand metric tons of CO2 equivalent) in 2000 in Philippines to that in Poland?
Keep it short and to the point. 1.17. What is the ratio of the SF6 emissions (in thousand metric tons of CO2 equivalent) of 2005 in Philippines to that in Poland?
Ensure brevity in your answer.  1.67. What is the ratio of the SF6 emissions (in thousand metric tons of CO2 equivalent) of 2008 in Philippines to that in Poland?
Give a very brief answer. 1.68. What is the difference between the highest and the second highest SF6 emissions (in thousand metric tons of CO2 equivalent) of 1990?
Give a very brief answer. 1254.6. What is the difference between the highest and the second highest SF6 emissions (in thousand metric tons of CO2 equivalent) in 2000?
Your answer should be very brief. 636. What is the difference between the highest and the second highest SF6 emissions (in thousand metric tons of CO2 equivalent) in 2005?
Ensure brevity in your answer.  454.1. What is the difference between the highest and the second highest SF6 emissions (in thousand metric tons of CO2 equivalent) in 2008?
Provide a short and direct response. 529.9. What is the difference between the highest and the lowest SF6 emissions (in thousand metric tons of CO2 equivalent) in 1990?
Your response must be concise. 2214.2. What is the difference between the highest and the lowest SF6 emissions (in thousand metric tons of CO2 equivalent) in 2000?
Offer a very short reply. 924.8. What is the difference between the highest and the lowest SF6 emissions (in thousand metric tons of CO2 equivalent) in 2005?
Provide a short and direct response. 766. What is the difference between the highest and the lowest SF6 emissions (in thousand metric tons of CO2 equivalent) of 2008?
Offer a terse response. 890.1. 